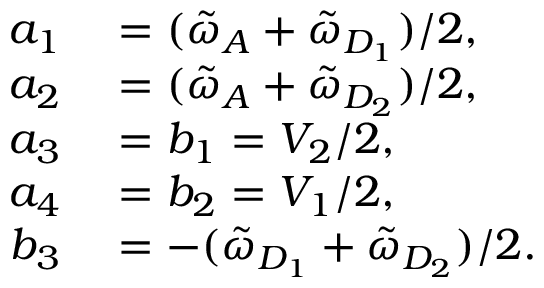Convert formula to latex. <formula><loc_0><loc_0><loc_500><loc_500>\begin{array} { r l } { a _ { 1 } } & = ( \tilde { \omega } _ { A } + \tilde { \omega } _ { D _ { 1 } } ) / 2 , } \\ { a _ { 2 } } & = ( \tilde { \omega } _ { A } + \tilde { \omega } _ { D _ { 2 } } ) / 2 , } \\ { a _ { 3 } } & = b _ { 1 } = V _ { 2 } / 2 , } \\ { a _ { 4 } } & = b _ { 2 } = V _ { 1 } / 2 , } \\ { b _ { 3 } } & = - ( \tilde { \omega } _ { D _ { 1 } } + \tilde { \omega } _ { D _ { 2 } } ) / 2 . } \end{array}</formula> 